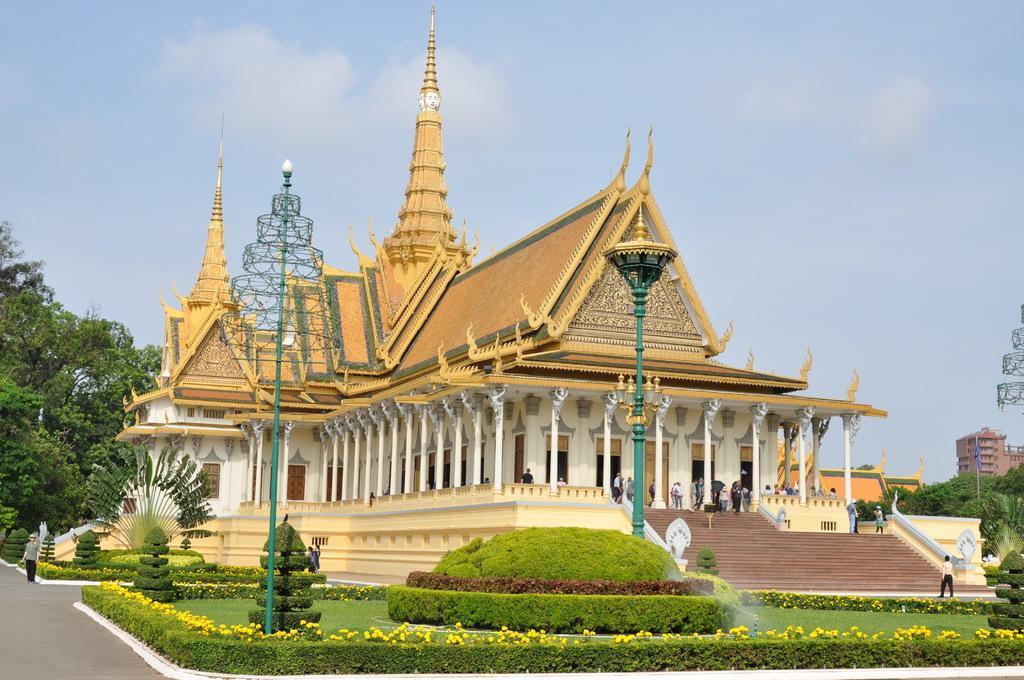How would you summarize this image in a sentence or two? In this image, this looks like a palace. These are the pillars. I can see the sculptures. There are few people walking. These are the stairs. This looks like a light pole. I can see the bushes and plants with the flowers. These are the trees. Here is a person standing on the pathway. In the background, that looks like a building. 